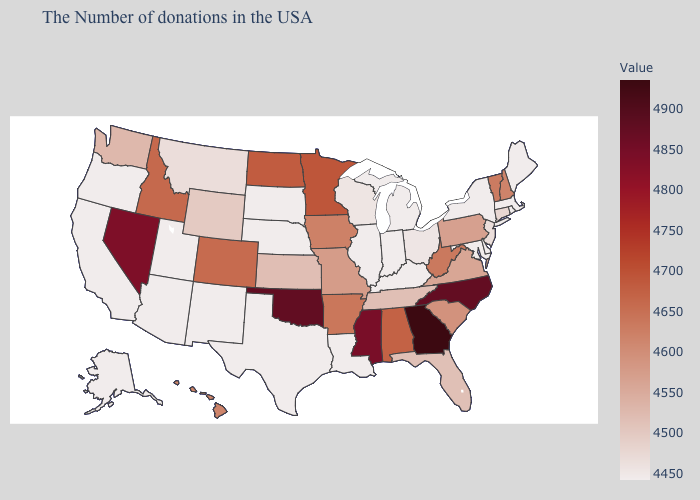Does New Jersey have the highest value in the USA?
Give a very brief answer. No. Does Iowa have a higher value than Delaware?
Concise answer only. Yes. Which states have the lowest value in the Northeast?
Short answer required. Maine, Massachusetts, Rhode Island, New York. Among the states that border Oklahoma , does Arkansas have the lowest value?
Be succinct. No. Which states hav the highest value in the Northeast?
Answer briefly. Vermont. 